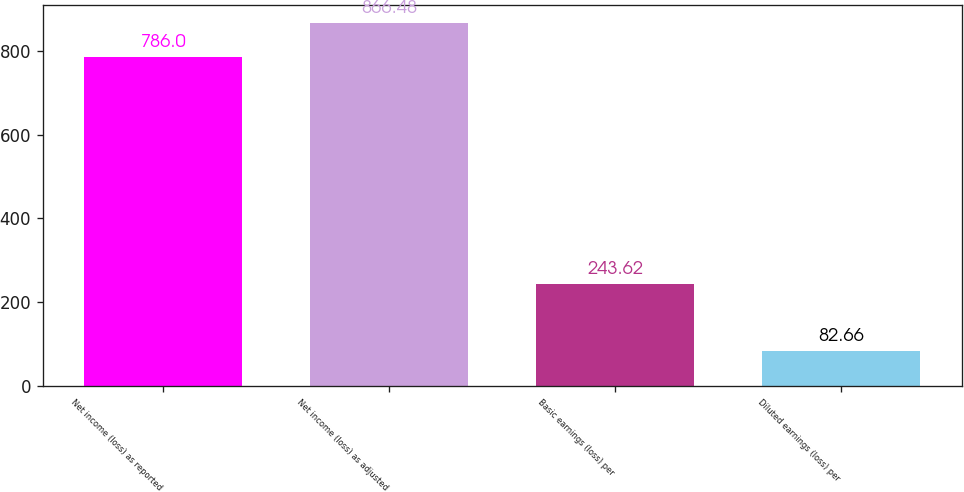Convert chart. <chart><loc_0><loc_0><loc_500><loc_500><bar_chart><fcel>Net income (loss) as reported<fcel>Net income (loss) as adjusted<fcel>Basic earnings (loss) per<fcel>Diluted earnings (loss) per<nl><fcel>786<fcel>866.48<fcel>243.62<fcel>82.66<nl></chart> 